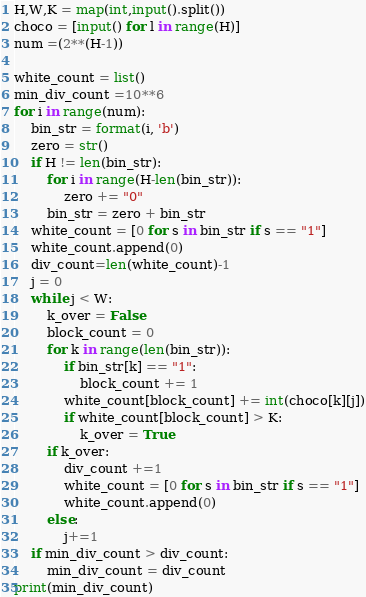Convert code to text. <code><loc_0><loc_0><loc_500><loc_500><_Python_>H,W,K = map(int,input().split())
choco = [input() for l in range(H)]
num =(2**(H-1))

white_count = list()
min_div_count =10**6
for i in range(num):
    bin_str = format(i, 'b')
    zero = str()
    if H != len(bin_str):
        for i in range(H-len(bin_str)):
            zero += "0"
        bin_str = zero + bin_str
    white_count = [0 for s in bin_str if s == "1"]
    white_count.append(0)
    div_count=len(white_count)-1
    j = 0
    while j < W:
        k_over = False
        block_count = 0
        for k in range(len(bin_str)):
            if bin_str[k] == "1":
                block_count += 1
            white_count[block_count] += int(choco[k][j])
            if white_count[block_count] > K:
                k_over = True
        if k_over:
            div_count +=1
            white_count = [0 for s in bin_str if s == "1"]
            white_count.append(0)
        else:
            j+=1
    if min_div_count > div_count:
        min_div_count = div_count
print(min_div_count)</code> 